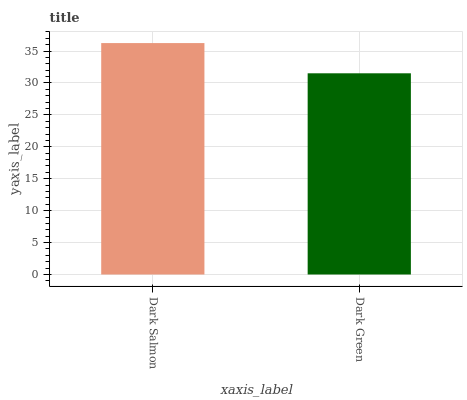Is Dark Green the minimum?
Answer yes or no. Yes. Is Dark Salmon the maximum?
Answer yes or no. Yes. Is Dark Green the maximum?
Answer yes or no. No. Is Dark Salmon greater than Dark Green?
Answer yes or no. Yes. Is Dark Green less than Dark Salmon?
Answer yes or no. Yes. Is Dark Green greater than Dark Salmon?
Answer yes or no. No. Is Dark Salmon less than Dark Green?
Answer yes or no. No. Is Dark Salmon the high median?
Answer yes or no. Yes. Is Dark Green the low median?
Answer yes or no. Yes. Is Dark Green the high median?
Answer yes or no. No. Is Dark Salmon the low median?
Answer yes or no. No. 